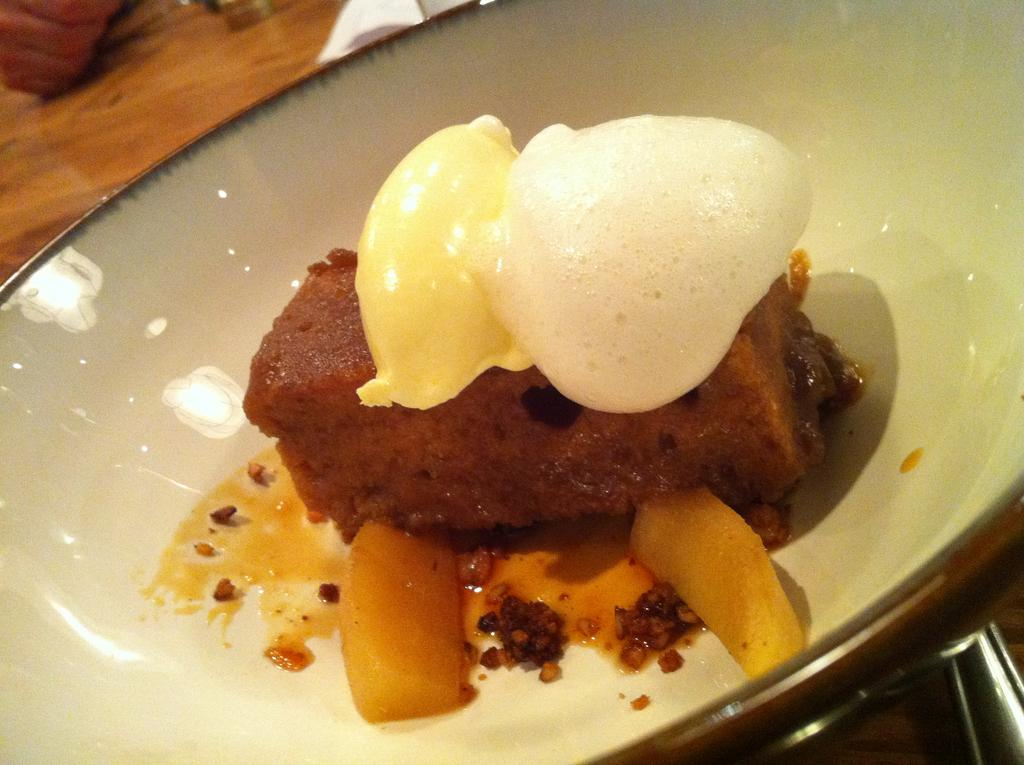What is present in the image related to food? There is food in the image. How is the food arranged or presented? The food is on a white color plate. What colors can be seen in the food? The food has cream, white, and brown colors. What is the color of the table where the plate is placed? The plate is placed on a brown color table. How many lizards are crawling on the food in the image? There are no lizards present in the image; it only features food on a plate. What type of bulb is used to illuminate the food in the image? There is no bulb or artificial lighting present in the image; it is likely a natural light setting. 